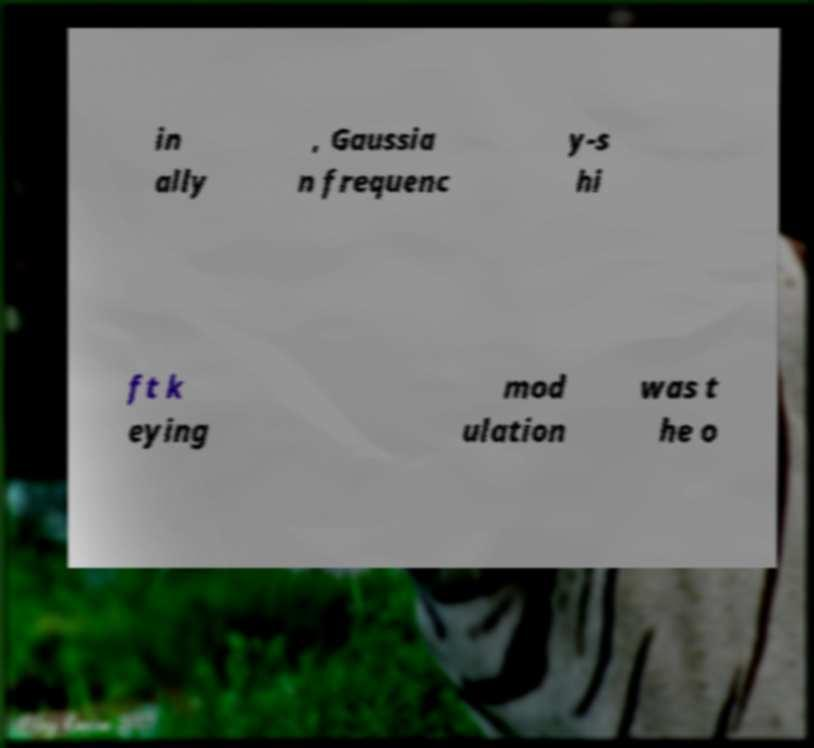I need the written content from this picture converted into text. Can you do that? in ally , Gaussia n frequenc y-s hi ft k eying mod ulation was t he o 